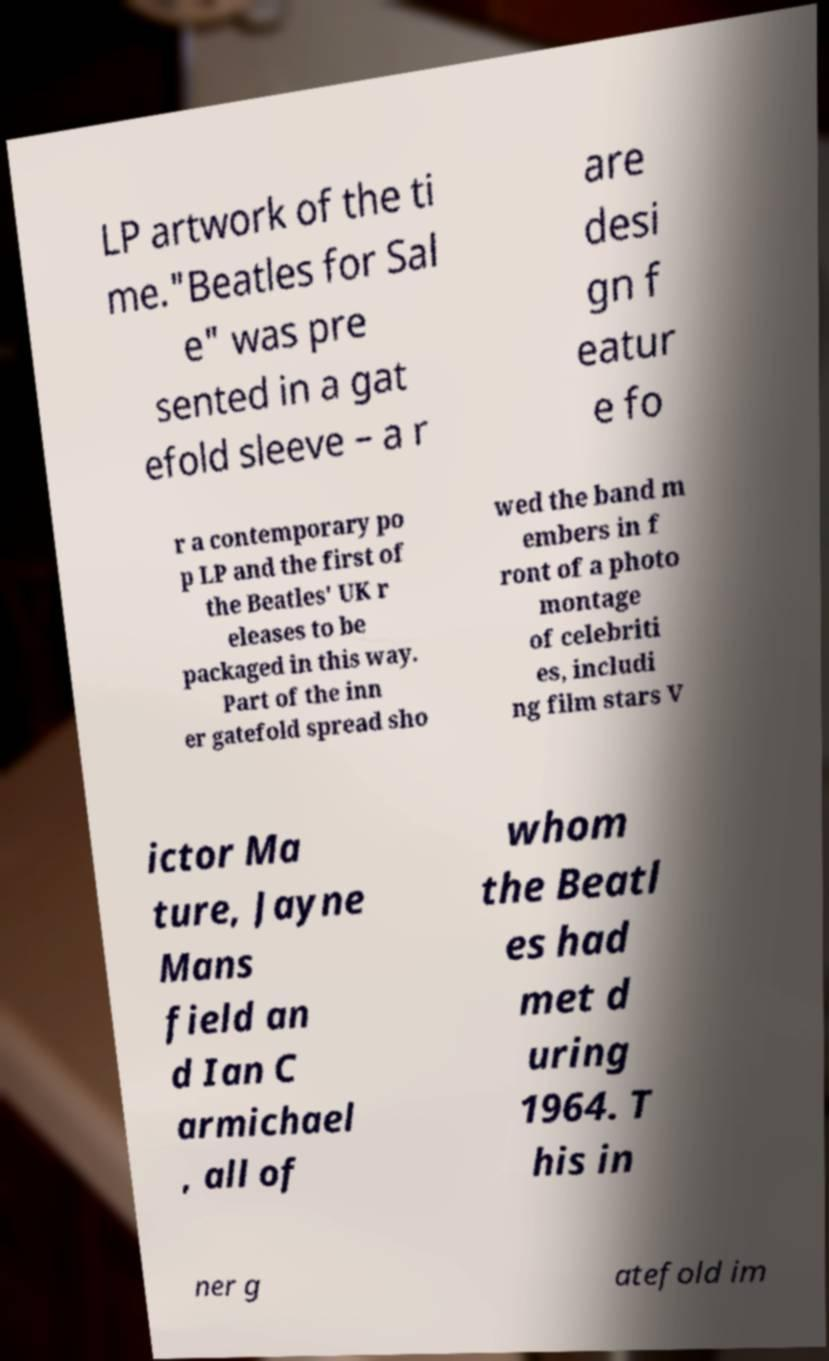Could you assist in decoding the text presented in this image and type it out clearly? LP artwork of the ti me."Beatles for Sal e" was pre sented in a gat efold sleeve – a r are desi gn f eatur e fo r a contemporary po p LP and the first of the Beatles' UK r eleases to be packaged in this way. Part of the inn er gatefold spread sho wed the band m embers in f ront of a photo montage of celebriti es, includi ng film stars V ictor Ma ture, Jayne Mans field an d Ian C armichael , all of whom the Beatl es had met d uring 1964. T his in ner g atefold im 